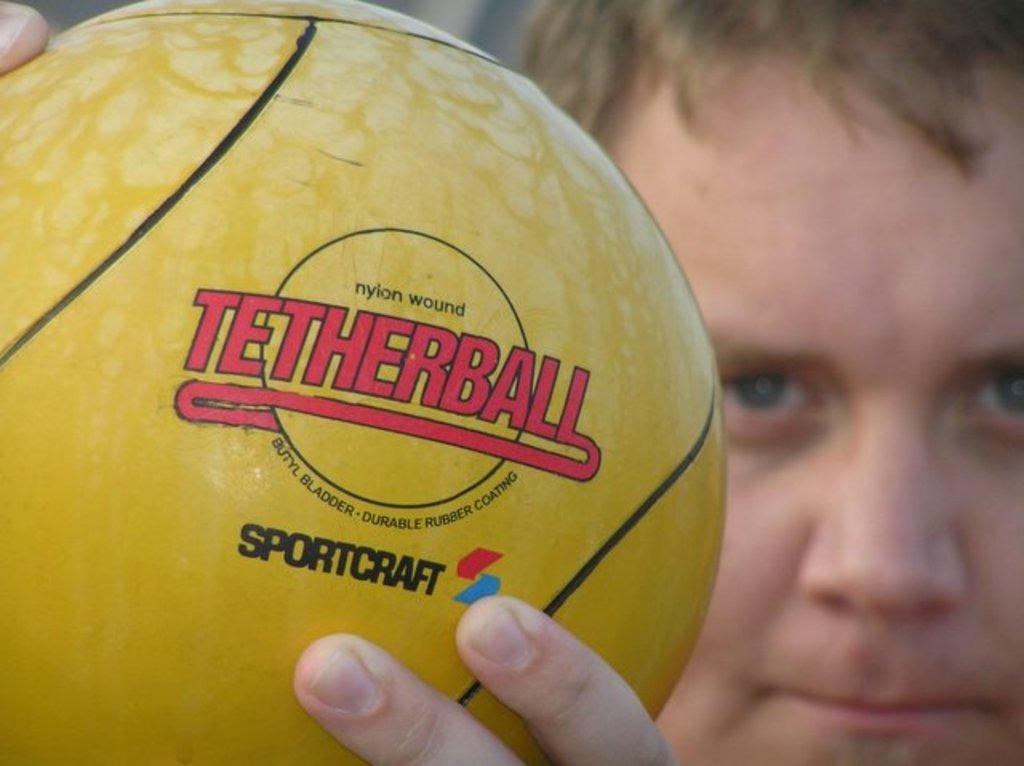<image>
Describe the image concisely. A boy holds a yellow tetherball manufactured by Sportcraft. 